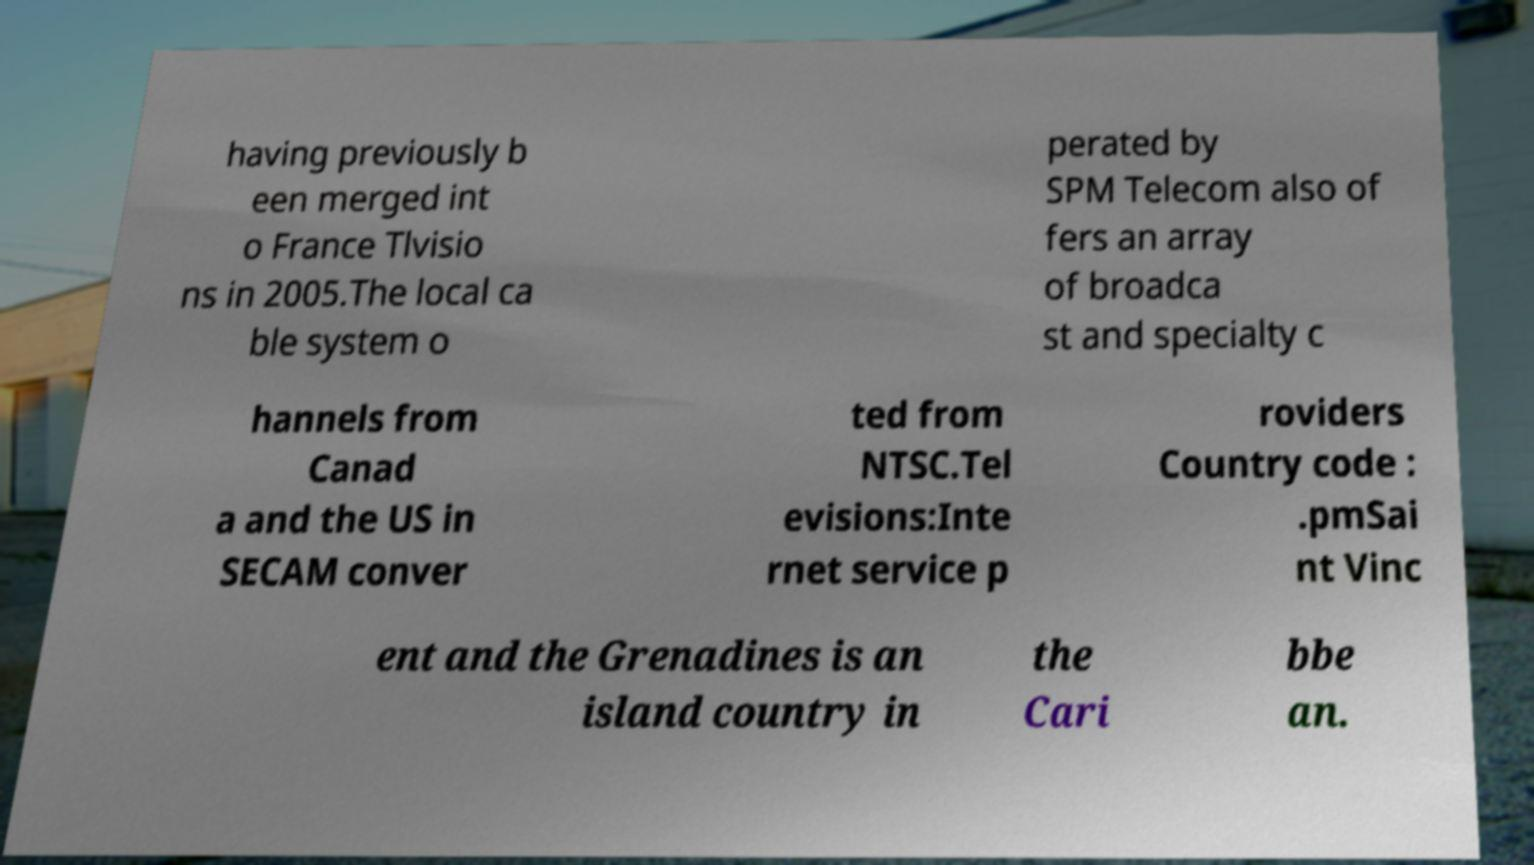Could you extract and type out the text from this image? having previously b een merged int o France Tlvisio ns in 2005.The local ca ble system o perated by SPM Telecom also of fers an array of broadca st and specialty c hannels from Canad a and the US in SECAM conver ted from NTSC.Tel evisions:Inte rnet service p roviders Country code : .pmSai nt Vinc ent and the Grenadines is an island country in the Cari bbe an. 